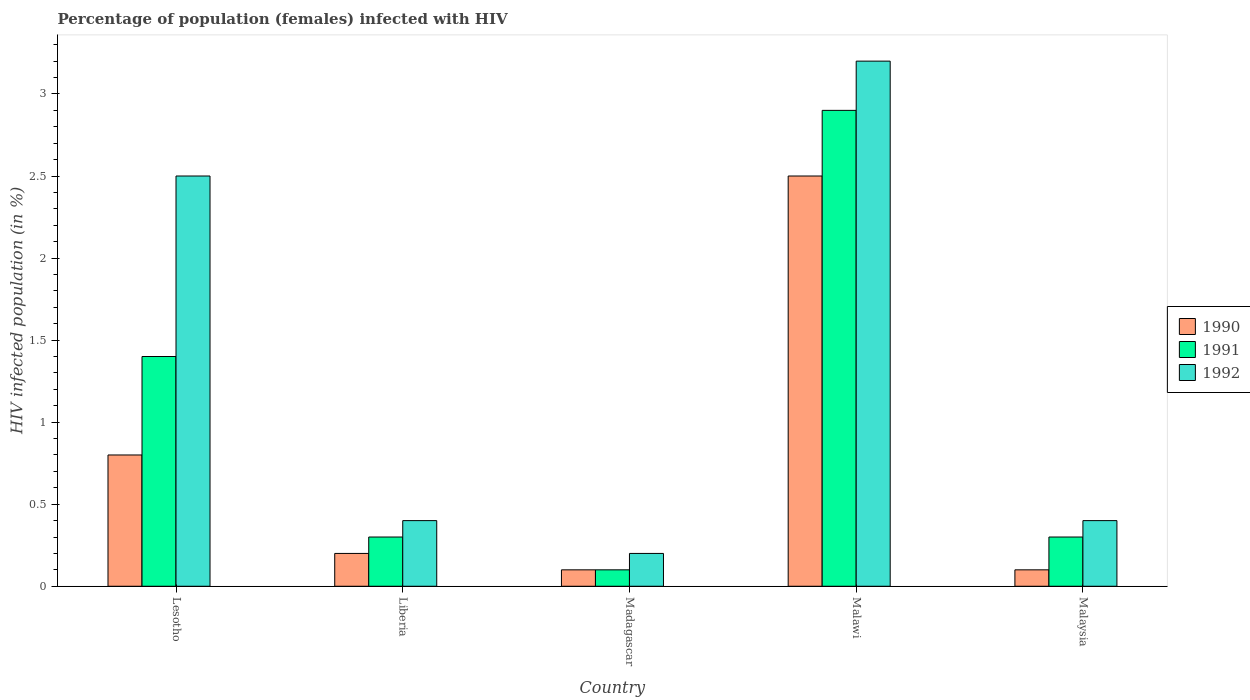What is the label of the 2nd group of bars from the left?
Offer a very short reply. Liberia. In how many cases, is the number of bars for a given country not equal to the number of legend labels?
Your answer should be very brief. 0. What is the percentage of HIV infected female population in 1990 in Liberia?
Make the answer very short. 0.2. In which country was the percentage of HIV infected female population in 1992 maximum?
Offer a terse response. Malawi. In which country was the percentage of HIV infected female population in 1991 minimum?
Give a very brief answer. Madagascar. What is the total percentage of HIV infected female population in 1992 in the graph?
Provide a short and direct response. 6.7. What is the difference between the percentage of HIV infected female population in 1990 in Lesotho and that in Malawi?
Provide a short and direct response. -1.7. What is the difference between the percentage of HIV infected female population in 1991 in Madagascar and the percentage of HIV infected female population in 1992 in Liberia?
Keep it short and to the point. -0.3. What is the average percentage of HIV infected female population in 1992 per country?
Provide a succinct answer. 1.34. What is the difference between the percentage of HIV infected female population of/in 1990 and percentage of HIV infected female population of/in 1992 in Malawi?
Offer a terse response. -0.7. What is the difference between the highest and the second highest percentage of HIV infected female population in 1991?
Offer a very short reply. -1.1. In how many countries, is the percentage of HIV infected female population in 1991 greater than the average percentage of HIV infected female population in 1991 taken over all countries?
Your answer should be very brief. 2. Is it the case that in every country, the sum of the percentage of HIV infected female population in 1992 and percentage of HIV infected female population in 1990 is greater than the percentage of HIV infected female population in 1991?
Offer a terse response. Yes. How many legend labels are there?
Offer a terse response. 3. What is the title of the graph?
Your answer should be compact. Percentage of population (females) infected with HIV. Does "1995" appear as one of the legend labels in the graph?
Your response must be concise. No. What is the label or title of the Y-axis?
Your response must be concise. HIV infected population (in %). What is the HIV infected population (in %) of 1991 in Lesotho?
Make the answer very short. 1.4. What is the HIV infected population (in %) of 1992 in Lesotho?
Your response must be concise. 2.5. What is the HIV infected population (in %) in 1990 in Liberia?
Your response must be concise. 0.2. What is the HIV infected population (in %) of 1990 in Madagascar?
Your answer should be very brief. 0.1. What is the HIV infected population (in %) in 1991 in Madagascar?
Give a very brief answer. 0.1. What is the HIV infected population (in %) in 1992 in Madagascar?
Provide a short and direct response. 0.2. What is the HIV infected population (in %) in 1990 in Malawi?
Your answer should be very brief. 2.5. What is the HIV infected population (in %) in 1992 in Malawi?
Your answer should be very brief. 3.2. What is the HIV infected population (in %) in 1990 in Malaysia?
Keep it short and to the point. 0.1. Across all countries, what is the maximum HIV infected population (in %) of 1991?
Provide a short and direct response. 2.9. Across all countries, what is the minimum HIV infected population (in %) in 1990?
Keep it short and to the point. 0.1. Across all countries, what is the minimum HIV infected population (in %) of 1991?
Provide a succinct answer. 0.1. Across all countries, what is the minimum HIV infected population (in %) in 1992?
Offer a terse response. 0.2. What is the total HIV infected population (in %) in 1992 in the graph?
Make the answer very short. 6.7. What is the difference between the HIV infected population (in %) in 1990 in Lesotho and that in Liberia?
Provide a succinct answer. 0.6. What is the difference between the HIV infected population (in %) in 1991 in Lesotho and that in Liberia?
Your answer should be compact. 1.1. What is the difference between the HIV infected population (in %) of 1992 in Lesotho and that in Liberia?
Provide a short and direct response. 2.1. What is the difference between the HIV infected population (in %) of 1990 in Lesotho and that in Madagascar?
Keep it short and to the point. 0.7. What is the difference between the HIV infected population (in %) in 1991 in Lesotho and that in Madagascar?
Your response must be concise. 1.3. What is the difference between the HIV infected population (in %) of 1991 in Lesotho and that in Malawi?
Your answer should be compact. -1.5. What is the difference between the HIV infected population (in %) of 1992 in Lesotho and that in Malawi?
Offer a very short reply. -0.7. What is the difference between the HIV infected population (in %) of 1990 in Lesotho and that in Malaysia?
Your answer should be very brief. 0.7. What is the difference between the HIV infected population (in %) in 1991 in Lesotho and that in Malaysia?
Keep it short and to the point. 1.1. What is the difference between the HIV infected population (in %) of 1992 in Lesotho and that in Malaysia?
Provide a succinct answer. 2.1. What is the difference between the HIV infected population (in %) in 1990 in Liberia and that in Madagascar?
Provide a succinct answer. 0.1. What is the difference between the HIV infected population (in %) in 1992 in Liberia and that in Madagascar?
Ensure brevity in your answer.  0.2. What is the difference between the HIV infected population (in %) of 1992 in Liberia and that in Malawi?
Your answer should be very brief. -2.8. What is the difference between the HIV infected population (in %) in 1991 in Liberia and that in Malaysia?
Keep it short and to the point. 0. What is the difference between the HIV infected population (in %) of 1992 in Madagascar and that in Malawi?
Give a very brief answer. -3. What is the difference between the HIV infected population (in %) in 1990 in Madagascar and that in Malaysia?
Offer a terse response. 0. What is the difference between the HIV infected population (in %) in 1990 in Malawi and that in Malaysia?
Provide a succinct answer. 2.4. What is the difference between the HIV infected population (in %) in 1991 in Malawi and that in Malaysia?
Provide a succinct answer. 2.6. What is the difference between the HIV infected population (in %) of 1992 in Malawi and that in Malaysia?
Make the answer very short. 2.8. What is the difference between the HIV infected population (in %) of 1990 in Lesotho and the HIV infected population (in %) of 1992 in Liberia?
Ensure brevity in your answer.  0.4. What is the difference between the HIV infected population (in %) of 1991 in Lesotho and the HIV infected population (in %) of 1992 in Liberia?
Your answer should be very brief. 1. What is the difference between the HIV infected population (in %) of 1990 in Lesotho and the HIV infected population (in %) of 1992 in Madagascar?
Your answer should be very brief. 0.6. What is the difference between the HIV infected population (in %) of 1990 in Lesotho and the HIV infected population (in %) of 1992 in Malawi?
Your answer should be very brief. -2.4. What is the difference between the HIV infected population (in %) in 1991 in Lesotho and the HIV infected population (in %) in 1992 in Malawi?
Your response must be concise. -1.8. What is the difference between the HIV infected population (in %) in 1990 in Lesotho and the HIV infected population (in %) in 1991 in Malaysia?
Provide a short and direct response. 0.5. What is the difference between the HIV infected population (in %) in 1990 in Lesotho and the HIV infected population (in %) in 1992 in Malaysia?
Keep it short and to the point. 0.4. What is the difference between the HIV infected population (in %) of 1990 in Liberia and the HIV infected population (in %) of 1992 in Madagascar?
Provide a short and direct response. 0. What is the difference between the HIV infected population (in %) in 1991 in Liberia and the HIV infected population (in %) in 1992 in Madagascar?
Your answer should be compact. 0.1. What is the difference between the HIV infected population (in %) in 1990 in Liberia and the HIV infected population (in %) in 1992 in Malawi?
Keep it short and to the point. -3. What is the difference between the HIV infected population (in %) of 1990 in Liberia and the HIV infected population (in %) of 1991 in Malaysia?
Ensure brevity in your answer.  -0.1. What is the difference between the HIV infected population (in %) of 1991 in Madagascar and the HIV infected population (in %) of 1992 in Malawi?
Make the answer very short. -3.1. What is the difference between the HIV infected population (in %) of 1990 in Madagascar and the HIV infected population (in %) of 1992 in Malaysia?
Make the answer very short. -0.3. What is the difference between the HIV infected population (in %) of 1990 in Malawi and the HIV infected population (in %) of 1992 in Malaysia?
Make the answer very short. 2.1. What is the difference between the HIV infected population (in %) of 1991 in Malawi and the HIV infected population (in %) of 1992 in Malaysia?
Offer a very short reply. 2.5. What is the average HIV infected population (in %) of 1990 per country?
Your answer should be compact. 0.74. What is the average HIV infected population (in %) of 1992 per country?
Your answer should be very brief. 1.34. What is the difference between the HIV infected population (in %) in 1990 and HIV infected population (in %) in 1991 in Lesotho?
Offer a terse response. -0.6. What is the difference between the HIV infected population (in %) in 1991 and HIV infected population (in %) in 1992 in Liberia?
Your answer should be very brief. -0.1. What is the difference between the HIV infected population (in %) of 1990 and HIV infected population (in %) of 1992 in Madagascar?
Offer a terse response. -0.1. What is the difference between the HIV infected population (in %) of 1991 and HIV infected population (in %) of 1992 in Madagascar?
Give a very brief answer. -0.1. What is the difference between the HIV infected population (in %) of 1991 and HIV infected population (in %) of 1992 in Malaysia?
Provide a short and direct response. -0.1. What is the ratio of the HIV infected population (in %) of 1990 in Lesotho to that in Liberia?
Provide a succinct answer. 4. What is the ratio of the HIV infected population (in %) in 1991 in Lesotho to that in Liberia?
Give a very brief answer. 4.67. What is the ratio of the HIV infected population (in %) of 1992 in Lesotho to that in Liberia?
Make the answer very short. 6.25. What is the ratio of the HIV infected population (in %) of 1990 in Lesotho to that in Malawi?
Make the answer very short. 0.32. What is the ratio of the HIV infected population (in %) of 1991 in Lesotho to that in Malawi?
Offer a terse response. 0.48. What is the ratio of the HIV infected population (in %) in 1992 in Lesotho to that in Malawi?
Give a very brief answer. 0.78. What is the ratio of the HIV infected population (in %) of 1990 in Lesotho to that in Malaysia?
Offer a terse response. 8. What is the ratio of the HIV infected population (in %) of 1991 in Lesotho to that in Malaysia?
Provide a short and direct response. 4.67. What is the ratio of the HIV infected population (in %) of 1992 in Lesotho to that in Malaysia?
Keep it short and to the point. 6.25. What is the ratio of the HIV infected population (in %) in 1990 in Liberia to that in Madagascar?
Offer a terse response. 2. What is the ratio of the HIV infected population (in %) of 1991 in Liberia to that in Madagascar?
Your answer should be compact. 3. What is the ratio of the HIV infected population (in %) in 1990 in Liberia to that in Malawi?
Give a very brief answer. 0.08. What is the ratio of the HIV infected population (in %) in 1991 in Liberia to that in Malawi?
Give a very brief answer. 0.1. What is the ratio of the HIV infected population (in %) in 1990 in Madagascar to that in Malawi?
Offer a terse response. 0.04. What is the ratio of the HIV infected population (in %) of 1991 in Madagascar to that in Malawi?
Keep it short and to the point. 0.03. What is the ratio of the HIV infected population (in %) in 1992 in Madagascar to that in Malawi?
Provide a short and direct response. 0.06. What is the ratio of the HIV infected population (in %) of 1990 in Madagascar to that in Malaysia?
Your response must be concise. 1. What is the ratio of the HIV infected population (in %) in 1992 in Madagascar to that in Malaysia?
Keep it short and to the point. 0.5. What is the ratio of the HIV infected population (in %) of 1991 in Malawi to that in Malaysia?
Make the answer very short. 9.67. What is the difference between the highest and the second highest HIV infected population (in %) in 1991?
Provide a short and direct response. 1.5. What is the difference between the highest and the lowest HIV infected population (in %) of 1990?
Give a very brief answer. 2.4. What is the difference between the highest and the lowest HIV infected population (in %) in 1992?
Provide a short and direct response. 3. 